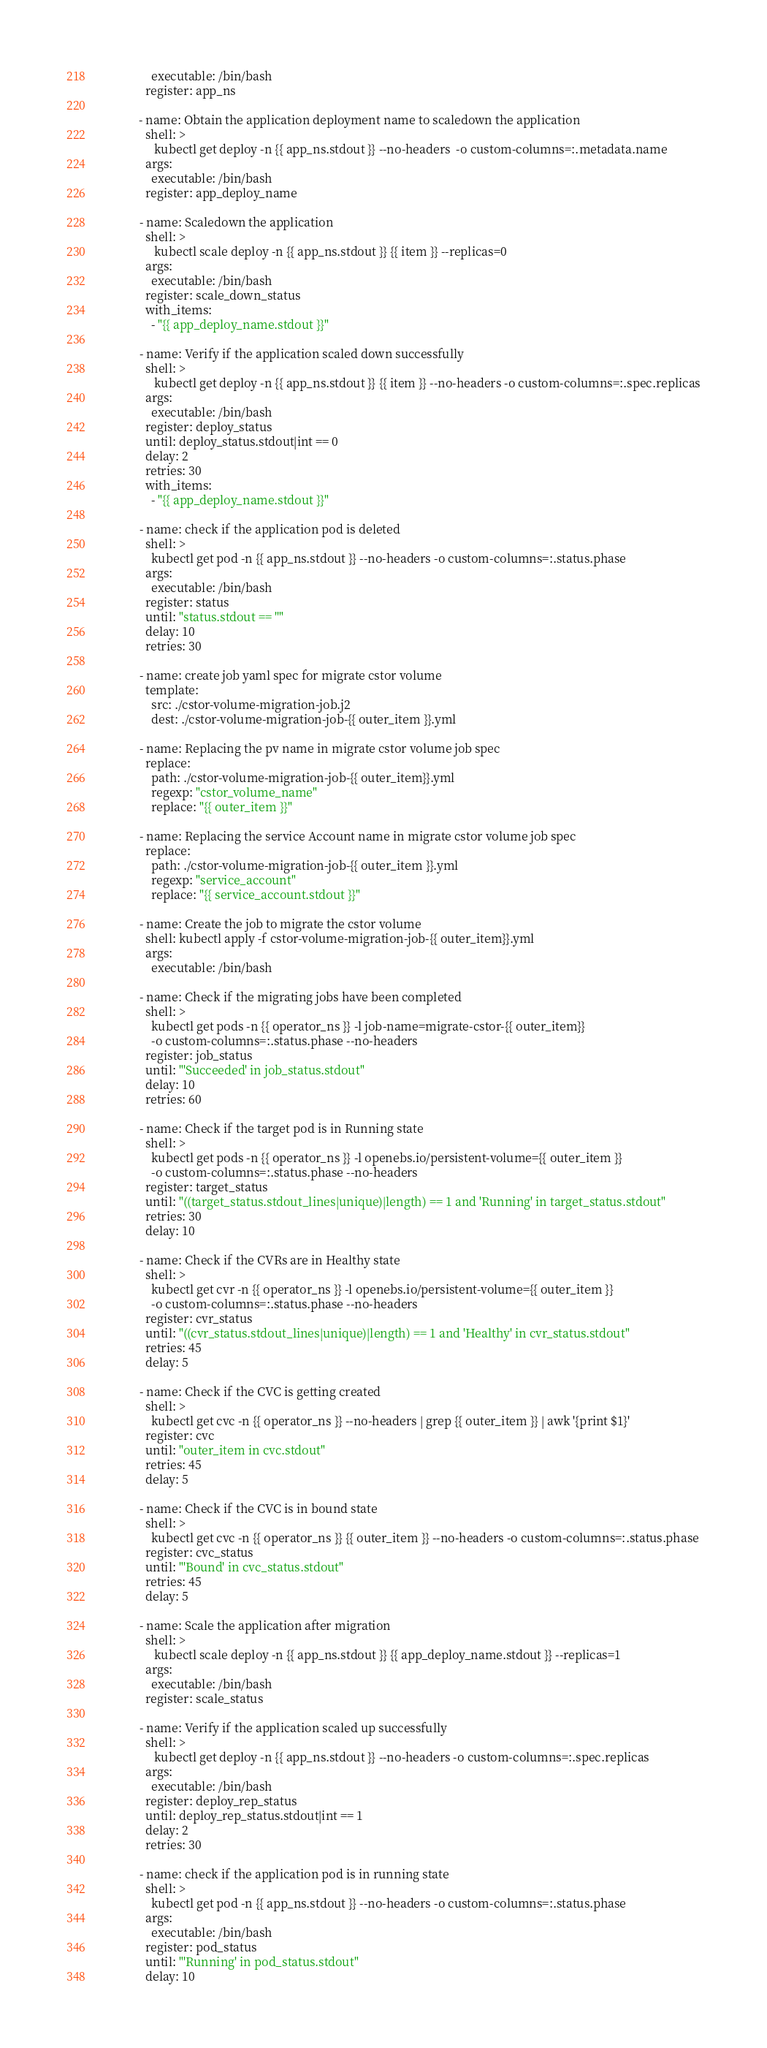Convert code to text. <code><loc_0><loc_0><loc_500><loc_500><_YAML_>                executable: /bin/bash
              register: app_ns

            - name: Obtain the application deployment name to scaledown the application
              shell: >
                 kubectl get deploy -n {{ app_ns.stdout }} --no-headers  -o custom-columns=:.metadata.name
              args:
                executable: /bin/bash
              register: app_deploy_name

            - name: Scaledown the application
              shell: >
                 kubectl scale deploy -n {{ app_ns.stdout }} {{ item }} --replicas=0
              args:
                executable: /bin/bash
              register: scale_down_status
              with_items:
                - "{{ app_deploy_name.stdout }}"
              
            - name: Verify if the application scaled down successfully
              shell: >
                 kubectl get deploy -n {{ app_ns.stdout }} {{ item }} --no-headers -o custom-columns=:.spec.replicas
              args:
                executable: /bin/bash
              register: deploy_status
              until: deploy_status.stdout|int == 0
              delay: 2
              retries: 30
              with_items:
                - "{{ app_deploy_name.stdout }}"

            - name: check if the application pod is deleted
              shell: >
                kubectl get pod -n {{ app_ns.stdout }} --no-headers -o custom-columns=:.status.phase
              args:
                executable: /bin/bash
              register: status
              until: "status.stdout == ''"
              delay: 10
              retries: 30              
            
            - name: create job yaml spec for migrate cstor volume
              template:
                src: ./cstor-volume-migration-job.j2
                dest: ./cstor-volume-migration-job-{{ outer_item }}.yml

            - name: Replacing the pv name in migrate cstor volume job spec
              replace:
                path: ./cstor-volume-migration-job-{{ outer_item}}.yml
                regexp: "cstor_volume_name"
                replace: "{{ outer_item }}"

            - name: Replacing the service Account name in migrate cstor volume job spec
              replace:
                path: ./cstor-volume-migration-job-{{ outer_item }}.yml
                regexp: "service_account"
                replace: "{{ service_account.stdout }}"

            - name: Create the job to migrate the cstor volume
              shell: kubectl apply -f cstor-volume-migration-job-{{ outer_item}}.yml
              args:
                executable: /bin/bash

            - name: Check if the migrating jobs have been completed
              shell: >
                kubectl get pods -n {{ operator_ns }} -l job-name=migrate-cstor-{{ outer_item}} 
                -o custom-columns=:.status.phase --no-headers
              register: job_status
              until: "'Succeeded' in job_status.stdout"
              delay: 10
              retries: 60

            - name: Check if the target pod is in Running state
              shell: >
                kubectl get pods -n {{ operator_ns }} -l openebs.io/persistent-volume={{ outer_item }}
                -o custom-columns=:.status.phase --no-headers
              register: target_status
              until: "((target_status.stdout_lines|unique)|length) == 1 and 'Running' in target_status.stdout"
              retries: 30
              delay: 10

            - name: Check if the CVRs are in Healthy state
              shell: >
                kubectl get cvr -n {{ operator_ns }} -l openebs.io/persistent-volume={{ outer_item }}
                -o custom-columns=:.status.phase --no-headers
              register: cvr_status
              until: "((cvr_status.stdout_lines|unique)|length) == 1 and 'Healthy' in cvr_status.stdout"
              retries: 45
              delay: 5

            - name: Check if the CVC is getting created 
              shell: >
                kubectl get cvc -n {{ operator_ns }} --no-headers | grep {{ outer_item }} | awk '{print $1}'
              register: cvc
              until: "outer_item in cvc.stdout"
              retries: 45
              delay: 5

            - name: Check if the CVC is in bound state
              shell: >
                kubectl get cvc -n {{ operator_ns }} {{ outer_item }} --no-headers -o custom-columns=:.status.phase
              register: cvc_status
              until: "'Bound' in cvc_status.stdout"
              retries: 45
              delay: 5

            - name: Scale the application after migration
              shell: >
                 kubectl scale deploy -n {{ app_ns.stdout }} {{ app_deploy_name.stdout }} --replicas=1
              args:
                executable: /bin/bash
              register: scale_status

            - name: Verify if the application scaled up successfully
              shell: >
                 kubectl get deploy -n {{ app_ns.stdout }} --no-headers -o custom-columns=:.spec.replicas
              args:
                executable: /bin/bash
              register: deploy_rep_status
              until: deploy_rep_status.stdout|int == 1
              delay: 2
              retries: 30
            
            - name: check if the application pod is in running state
              shell: >
                kubectl get pod -n {{ app_ns.stdout }} --no-headers -o custom-columns=:.status.phase
              args:
                executable: /bin/bash
              register: pod_status
              until: "'Running' in pod_status.stdout"
              delay: 10</code> 